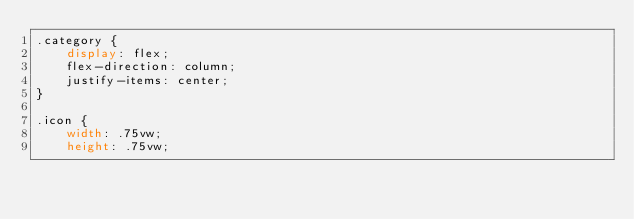Convert code to text. <code><loc_0><loc_0><loc_500><loc_500><_CSS_>.category {
    display: flex;
    flex-direction: column;
    justify-items: center;
}

.icon {
    width: .75vw;
    height: .75vw;</code> 